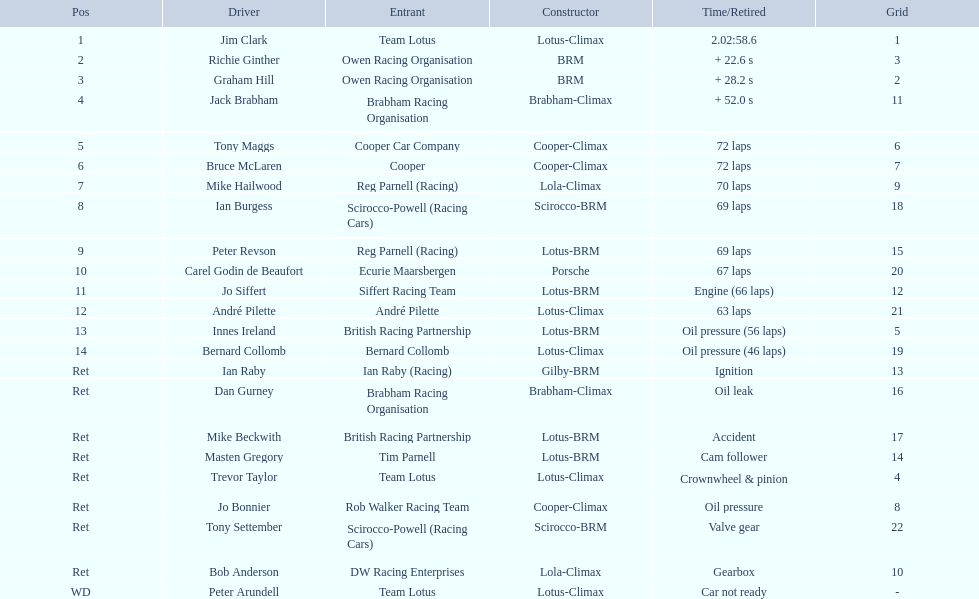Which drivers competed in the 1963 international gold cup? Jim Clark, Richie Ginther, Graham Hill, Jack Brabham, Tony Maggs, Bruce McLaren, Mike Hailwood, Ian Burgess, Peter Revson, Carel Godin de Beaufort, Jo Siffert, André Pilette, Innes Ireland, Bernard Collomb, Ian Raby, Dan Gurney, Mike Beckwith, Masten Gregory, Trevor Taylor, Jo Bonnier, Tony Settember, Bob Anderson, Peter Arundell. What was tony maggs' ranking? 5. How did jo siffert perform? 11. Help me parse the entirety of this table. {'header': ['Pos', 'Driver', 'Entrant', 'Constructor', 'Time/Retired', 'Grid'], 'rows': [['1', 'Jim Clark', 'Team Lotus', 'Lotus-Climax', '2.02:58.6', '1'], ['2', 'Richie Ginther', 'Owen Racing Organisation', 'BRM', '+ 22.6 s', '3'], ['3', 'Graham Hill', 'Owen Racing Organisation', 'BRM', '+ 28.2 s', '2'], ['4', 'Jack Brabham', 'Brabham Racing Organisation', 'Brabham-Climax', '+ 52.0 s', '11'], ['5', 'Tony Maggs', 'Cooper Car Company', 'Cooper-Climax', '72 laps', '6'], ['6', 'Bruce McLaren', 'Cooper', 'Cooper-Climax', '72 laps', '7'], ['7', 'Mike Hailwood', 'Reg Parnell (Racing)', 'Lola-Climax', '70 laps', '9'], ['8', 'Ian Burgess', 'Scirocco-Powell (Racing Cars)', 'Scirocco-BRM', '69 laps', '18'], ['9', 'Peter Revson', 'Reg Parnell (Racing)', 'Lotus-BRM', '69 laps', '15'], ['10', 'Carel Godin de Beaufort', 'Ecurie Maarsbergen', 'Porsche', '67 laps', '20'], ['11', 'Jo Siffert', 'Siffert Racing Team', 'Lotus-BRM', 'Engine (66 laps)', '12'], ['12', 'André Pilette', 'André Pilette', 'Lotus-Climax', '63 laps', '21'], ['13', 'Innes Ireland', 'British Racing Partnership', 'Lotus-BRM', 'Oil pressure (56 laps)', '5'], ['14', 'Bernard Collomb', 'Bernard Collomb', 'Lotus-Climax', 'Oil pressure (46 laps)', '19'], ['Ret', 'Ian Raby', 'Ian Raby (Racing)', 'Gilby-BRM', 'Ignition', '13'], ['Ret', 'Dan Gurney', 'Brabham Racing Organisation', 'Brabham-Climax', 'Oil leak', '16'], ['Ret', 'Mike Beckwith', 'British Racing Partnership', 'Lotus-BRM', 'Accident', '17'], ['Ret', 'Masten Gregory', 'Tim Parnell', 'Lotus-BRM', 'Cam follower', '14'], ['Ret', 'Trevor Taylor', 'Team Lotus', 'Lotus-Climax', 'Crownwheel & pinion', '4'], ['Ret', 'Jo Bonnier', 'Rob Walker Racing Team', 'Cooper-Climax', 'Oil pressure', '8'], ['Ret', 'Tony Settember', 'Scirocco-Powell (Racing Cars)', 'Scirocco-BRM', 'Valve gear', '22'], ['Ret', 'Bob Anderson', 'DW Racing Enterprises', 'Lola-Climax', 'Gearbox', '10'], ['WD', 'Peter Arundell', 'Team Lotus', 'Lotus-Climax', 'Car not ready', '-']]} Who finished sooner? Tony Maggs. 